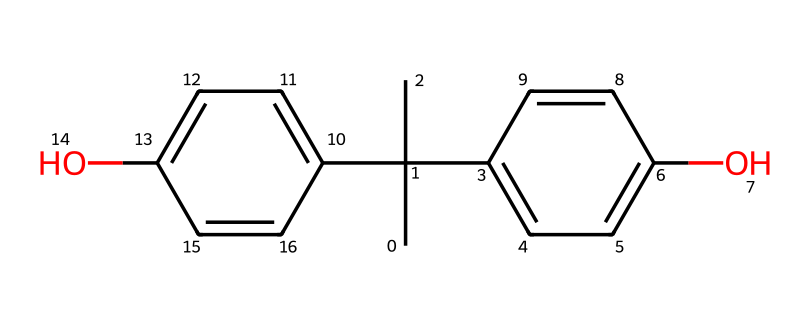What is the name of this toxic chemical? The SMILES representation corresponds to bisphenol A, a known toxic compound commonly found in plastics. The structure reveals two phenolic groups and a central carbon atom, which is characteristic of bisphenol compounds.
Answer: bisphenol A How many carbon atoms are present in this chemical? Counting the carbon atoms in the SMILES representation reveals there are 15 carbon atoms (C) in total. Each 'C' in the SMILES represents a carbon atom, and the branches and rings contribute to the total count.
Answer: 15 What type of bond connects the carbon atoms in this chemical? The carbon atoms in bisphenol A are primarily connected by single covalent bonds and some double bonds, as shown in the presence of aromatic rings, which indicate pi bonds as well.
Answer: single and double bonds What functional groups can be identified in this chemical? The structure contains two hydroxyl (-OH) functional groups, indicated by the 'O' and directly attached to carbon atoms in the aromatic rings. These groups are key to its properties.
Answer: hydroxyl groups Is this chemical classified as an endocrine disruptor? Bisphenol A is classified as an endocrine disruptor due to its structural similarity to hormones and its ability to interfere with hormonal pathways. This classification is supported by various studies that link BPA exposure to health issues.
Answer: yes How does the arrangement of rings in this chemical affect its toxicity? The arrangement of the aromatic rings in bisphenol A allows for effective interaction with hormone receptors due to its structural mimicry of estrogen. This enables it to disrupt normal biological processes, contributing to its toxicity.
Answer: structural mimicry What is a common source of exposure to this chemical? Common sources of exposure to bisphenol A include plastic products, such as containers and the plastic used in metro seats, where the chemical can leach into food or beverages.
Answer: plastic products 